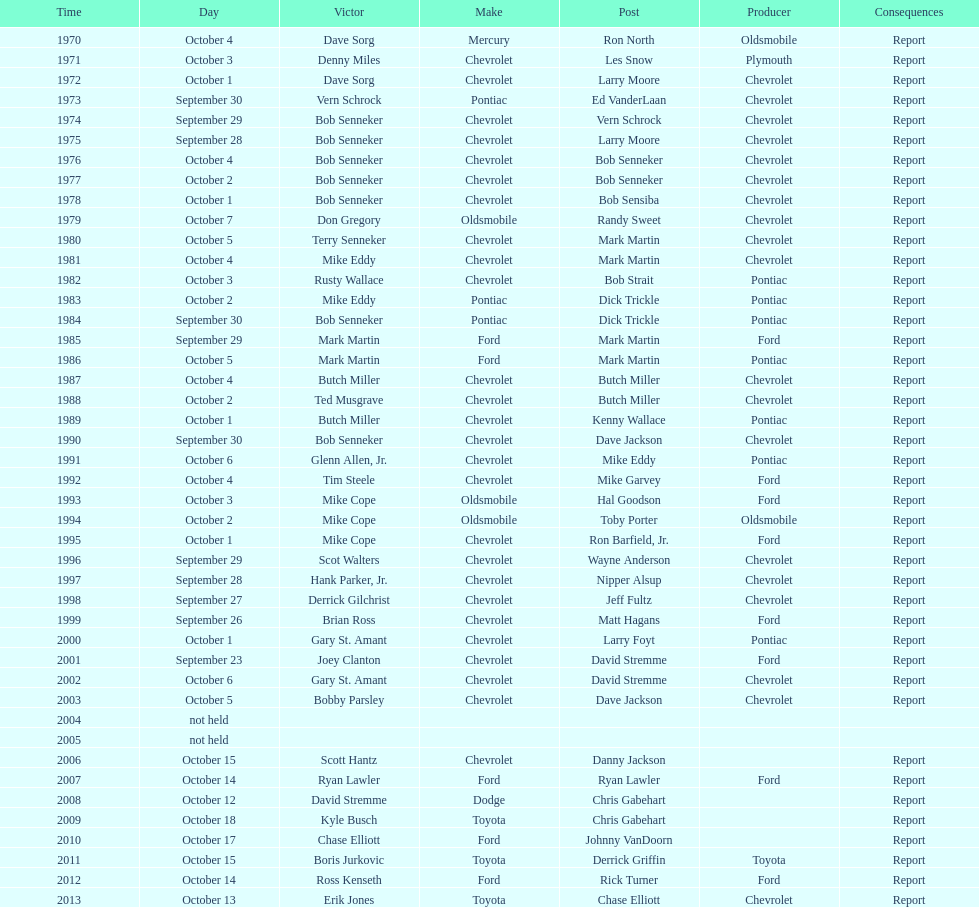Which make was used the least? Mercury. 